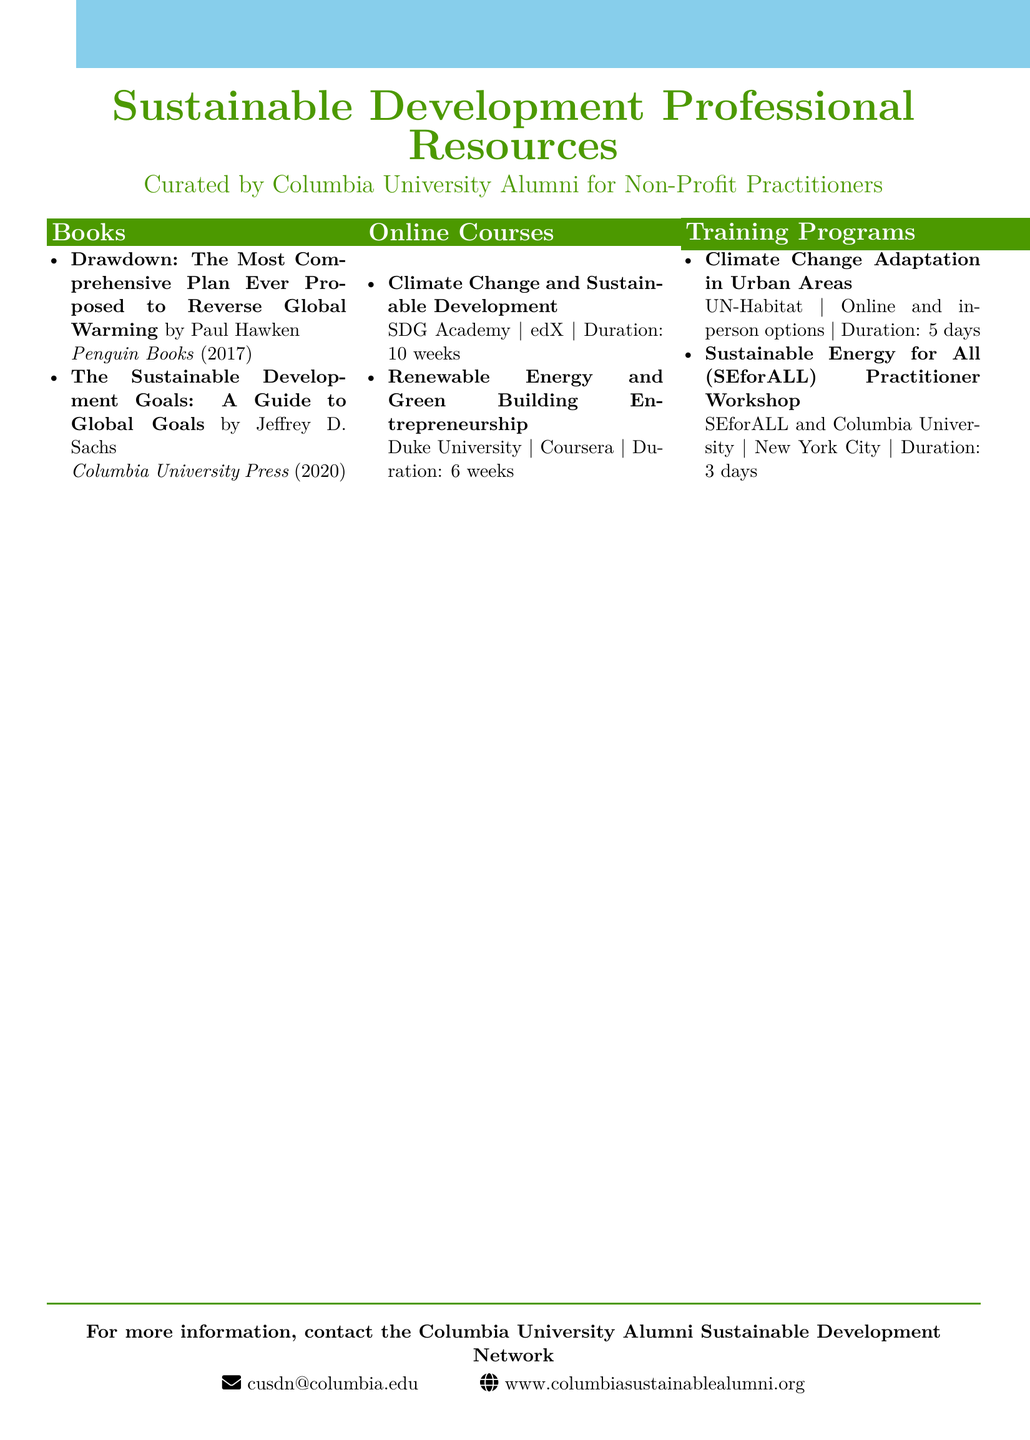What is the title of the book by Paul Hawken? The title of the book is provided in the catalog under the author's name and includes the phrase "The Most Comprehensive Plan Ever Proposed to Reverse Global Warming."
Answer: Drawdown What is the publication year of "The Sustainable Development Goals: A Guide to Global Goals"? The publication year can be found next to the book title in the catalog.
Answer: 2020 How long is the course "Climate Change and Sustainable Development"? The duration of the course is stated in the catalog after the course title and provider.
Answer: 10 weeks Where is the "Sustainable Energy for All (SEforALL) Practitioner Workshop" held? The location of the training program is indicated in the catalog.
Answer: New York City Who is the author of "Drawdown"? The author's name is mentioned next to the book title in the catalog.
Answer: Paul Hawken Which organization offers the "Climate Change Adaptation in Urban Areas" program? The provider of the training program is specified in the catalog entry.
Answer: UN-Habitat What is the duration of the "Renewable Energy and Green Building Entrepreneurship" course? The duration is noted at the end of the course entry in the catalog.
Answer: 6 weeks How many training programs are listed in the catalog? The total number of training programs can be counted from the training programs section of the document.
Answer: 2 